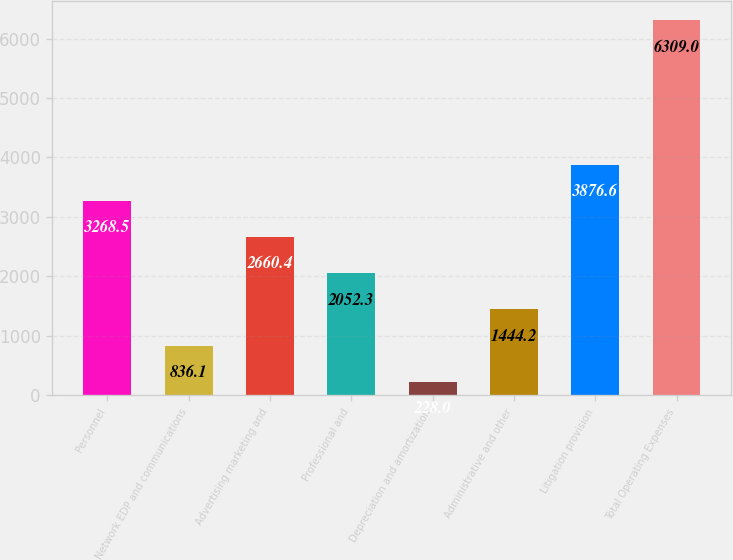Convert chart. <chart><loc_0><loc_0><loc_500><loc_500><bar_chart><fcel>Personnel<fcel>Network EDP and communications<fcel>Advertising marketing and<fcel>Professional and<fcel>Depreciation and amortization<fcel>Administrative and other<fcel>Litigation provision<fcel>Total Operating Expenses<nl><fcel>3268.5<fcel>836.1<fcel>2660.4<fcel>2052.3<fcel>228<fcel>1444.2<fcel>3876.6<fcel>6309<nl></chart> 